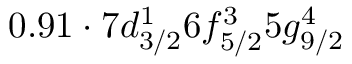Convert formula to latex. <formula><loc_0><loc_0><loc_500><loc_500>0 . 9 1 \cdot 7 d _ { 3 / 2 } ^ { 1 } 6 f _ { 5 / 2 } ^ { 3 } 5 g _ { 9 / 2 } ^ { 4 }</formula> 